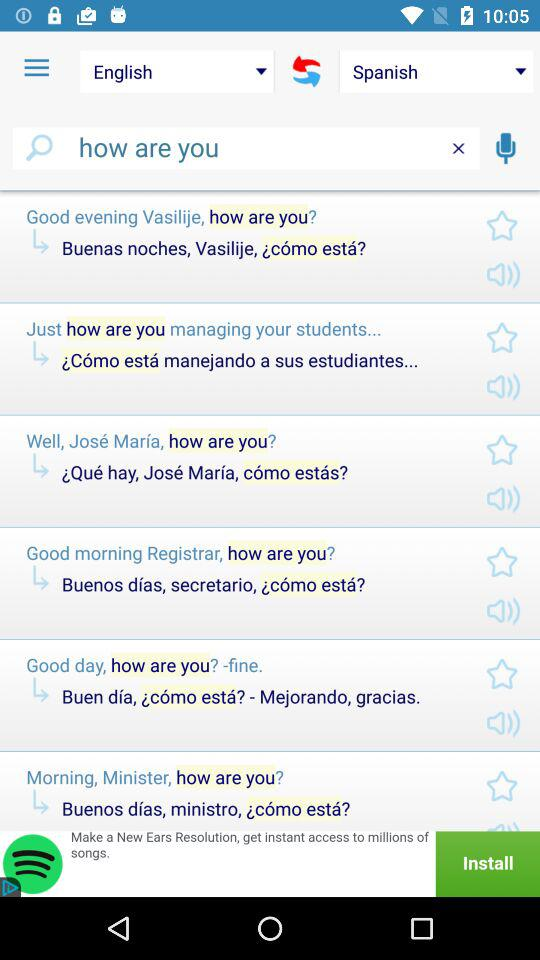How many languages are available on this screen?
Answer the question using a single word or phrase. 2 